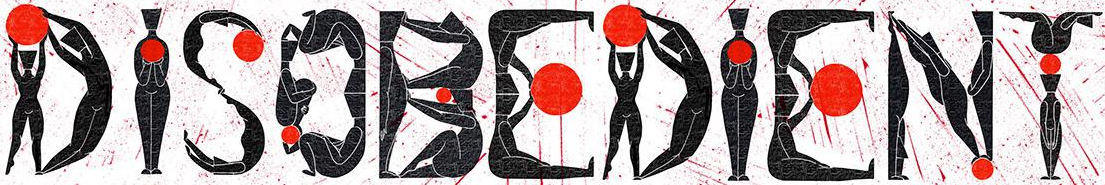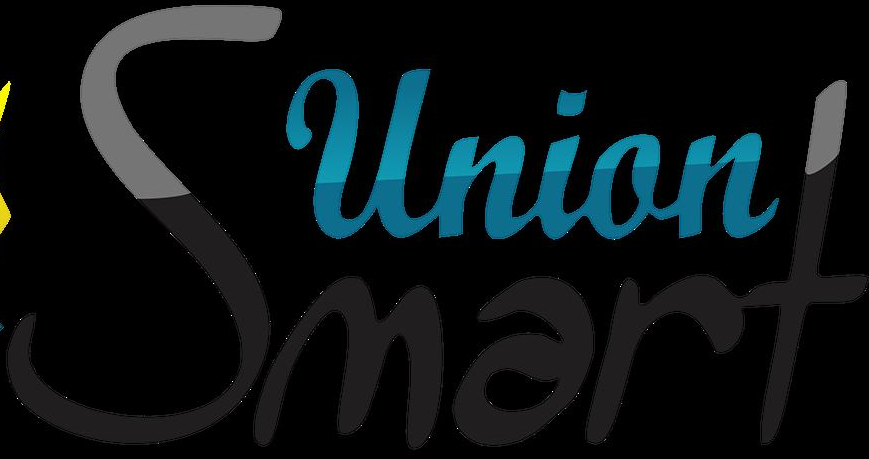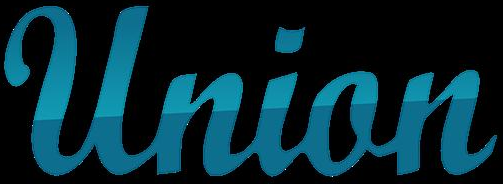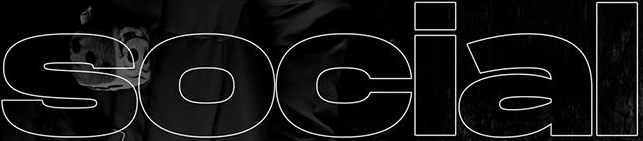Transcribe the words shown in these images in order, separated by a semicolon. DISOBEDIENT; Smart; Union; social 